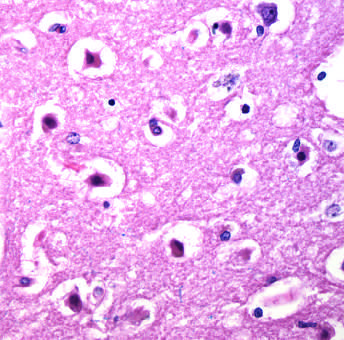re energy stores shrunken and eosinophilic?
Answer the question using a single word or phrase. No 